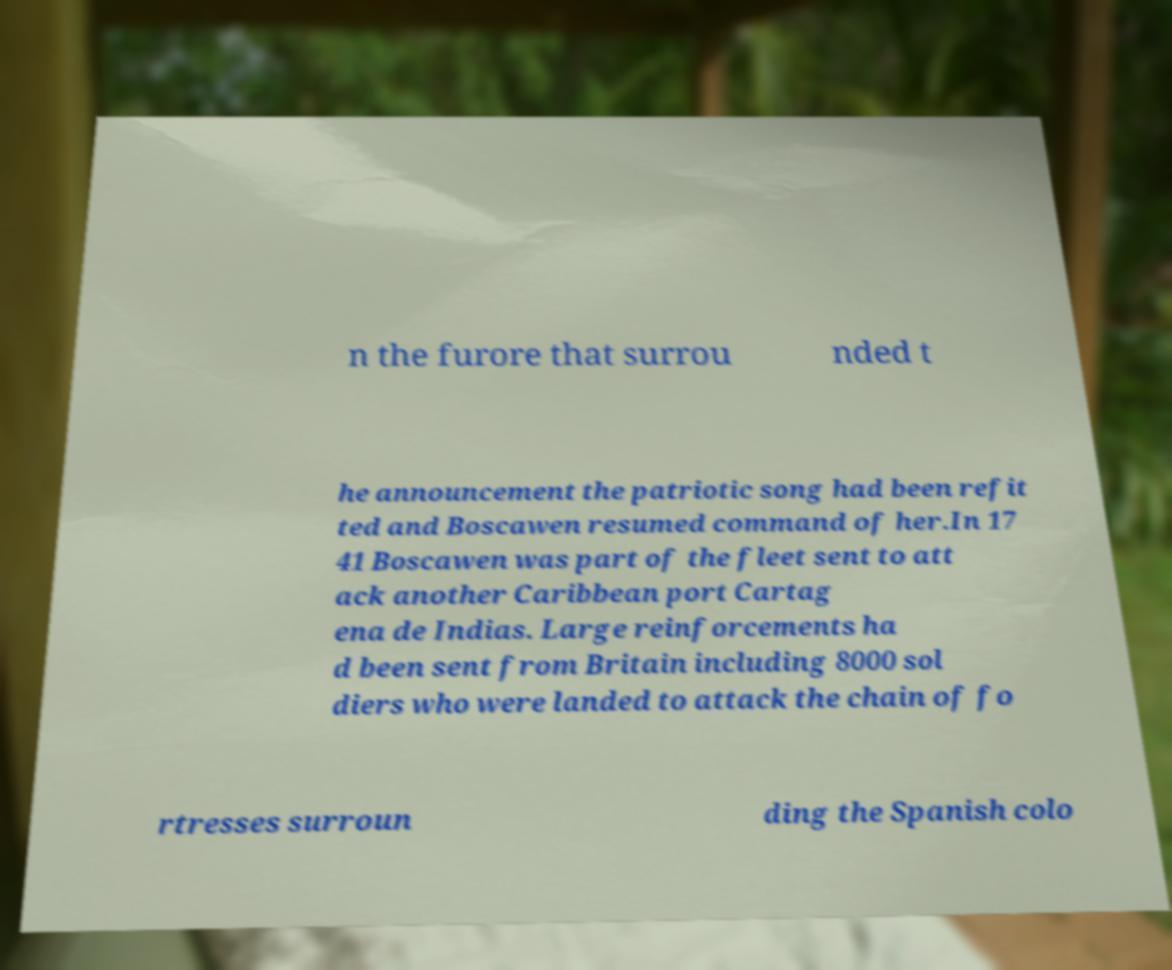Could you extract and type out the text from this image? n the furore that surrou nded t he announcement the patriotic song had been refit ted and Boscawen resumed command of her.In 17 41 Boscawen was part of the fleet sent to att ack another Caribbean port Cartag ena de Indias. Large reinforcements ha d been sent from Britain including 8000 sol diers who were landed to attack the chain of fo rtresses surroun ding the Spanish colo 